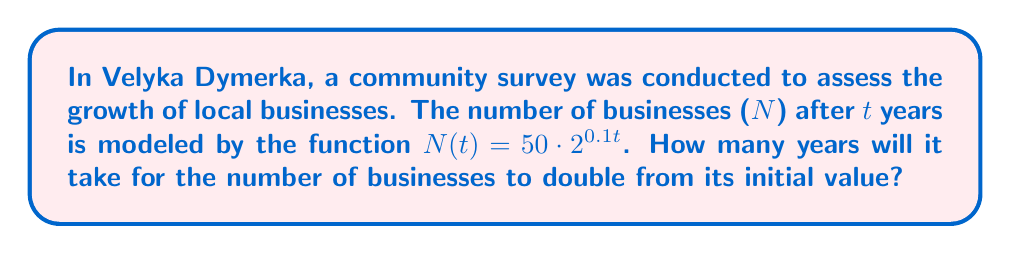Could you help me with this problem? Let's approach this step-by-step:

1) The initial number of businesses is when $t = 0$:
   $N(0) = 50 \cdot 2^{0.1 \cdot 0} = 50$

2) We want to find when the number of businesses reaches 100 (double the initial value):
   $100 = 50 \cdot 2^{0.1t}$

3) Divide both sides by 50:
   $2 = 2^{0.1t}$

4) Take the logarithm (base 2) of both sides:
   $\log_2(2) = \log_2(2^{0.1t})$

5) Simplify the left side and use the logarithm power rule on the right:
   $1 = 0.1t \cdot \log_2(2)$

6) Simplify further, noting that $\log_2(2) = 1$:
   $1 = 0.1t$

7) Solve for t:
   $t = 1 / 0.1 = 10$

Therefore, it will take 10 years for the number of businesses to double.
Answer: 10 years 